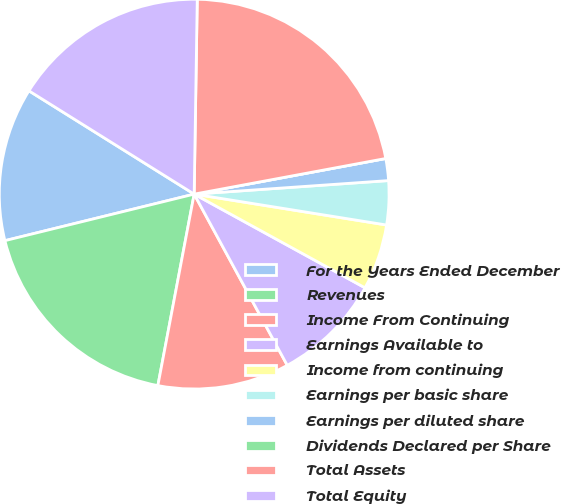Convert chart. <chart><loc_0><loc_0><loc_500><loc_500><pie_chart><fcel>For the Years Ended December<fcel>Revenues<fcel>Income From Continuing<fcel>Earnings Available to<fcel>Income from continuing<fcel>Earnings per basic share<fcel>Earnings per diluted share<fcel>Dividends Declared per Share<fcel>Total Assets<fcel>Total Equity<nl><fcel>12.73%<fcel>18.18%<fcel>10.91%<fcel>9.09%<fcel>5.45%<fcel>3.64%<fcel>1.82%<fcel>0.0%<fcel>21.82%<fcel>16.36%<nl></chart> 